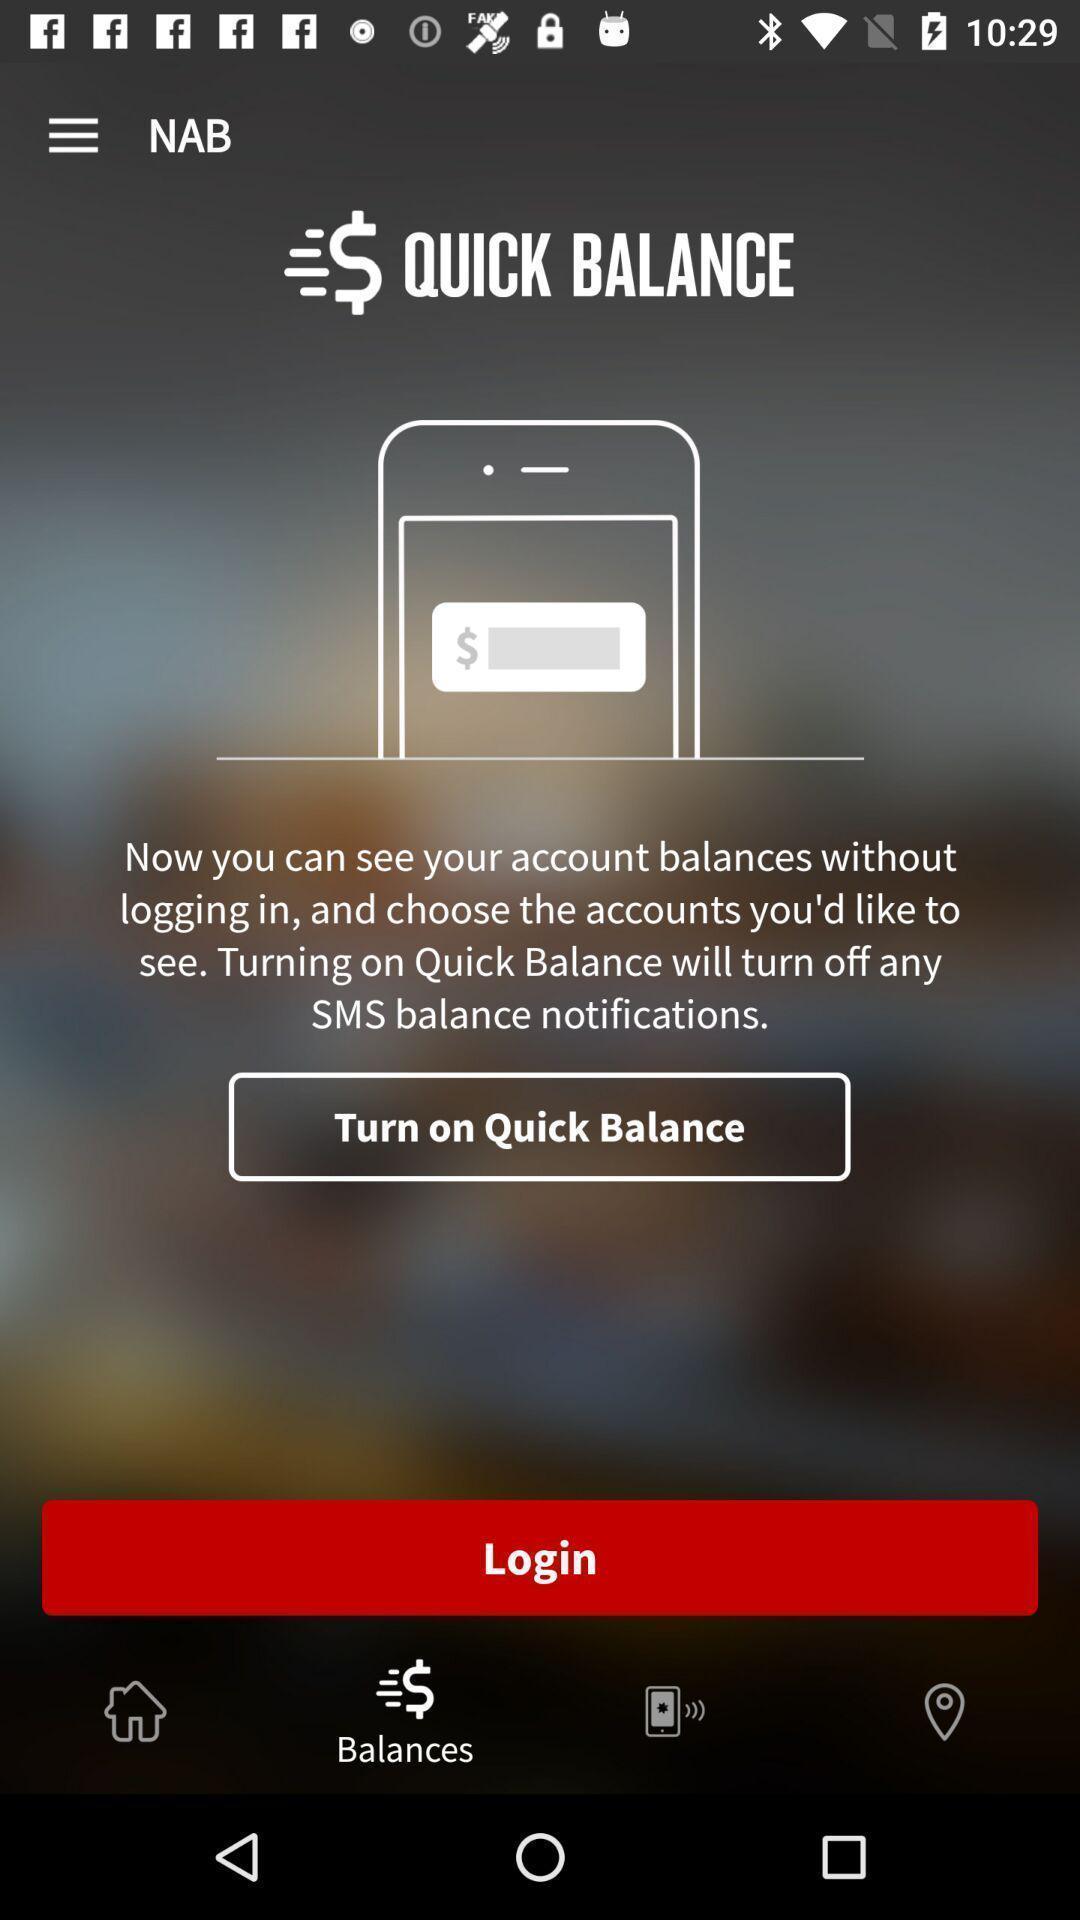What details can you identify in this image? Login page of mobile banking app. 